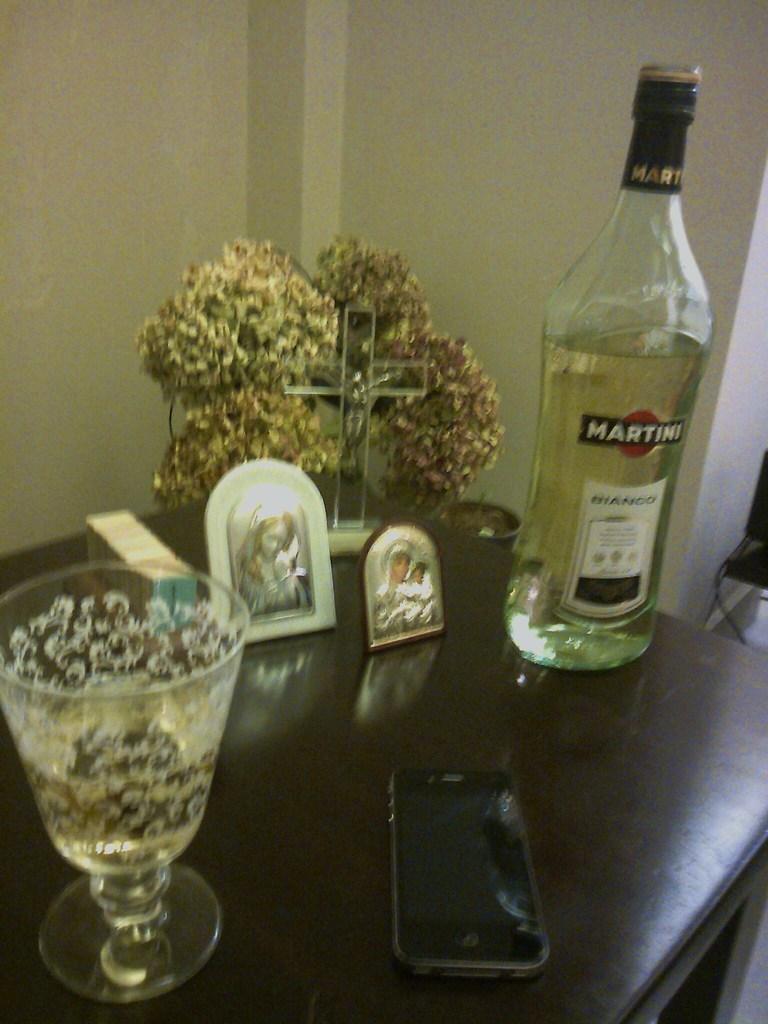Can you describe this image briefly? In this image there is a bottle, there is a glass, and there is a mobile phone and there are two photo frames on the table. In the background there is a wall and a pillar. 